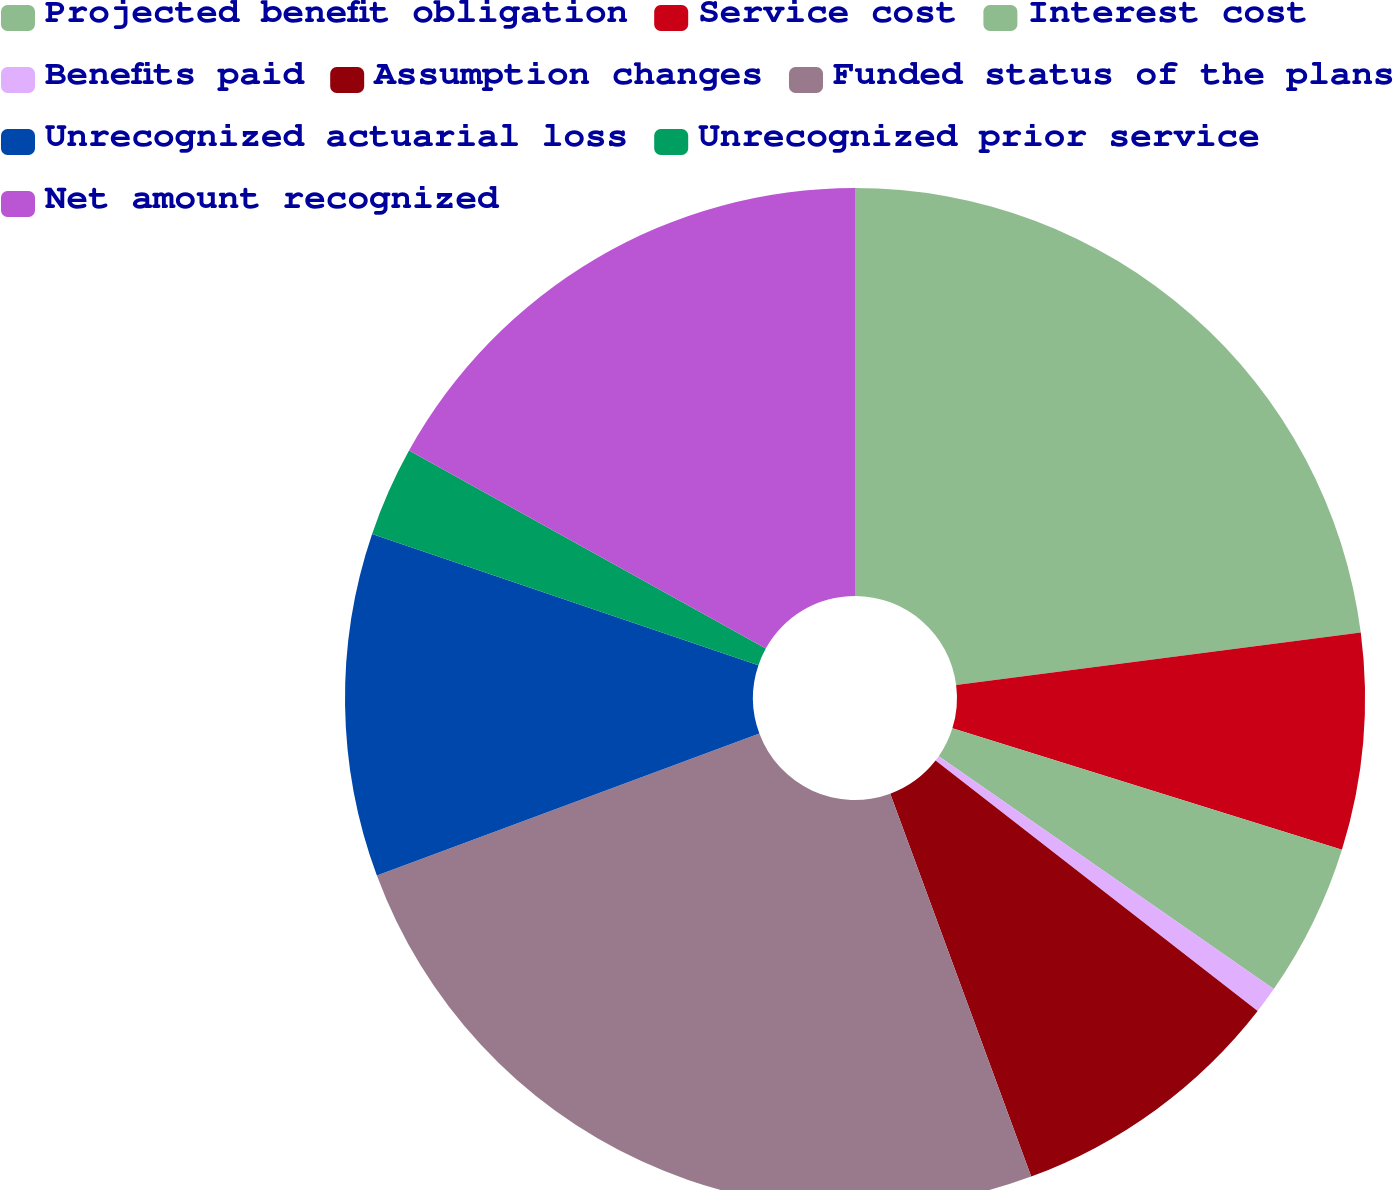Convert chart to OTSL. <chart><loc_0><loc_0><loc_500><loc_500><pie_chart><fcel>Projected benefit obligation<fcel>Service cost<fcel>Interest cost<fcel>Benefits paid<fcel>Assumption changes<fcel>Funded status of the plans<fcel>Unrecognized actuarial loss<fcel>Unrecognized prior service<fcel>Net amount recognized<nl><fcel>22.95%<fcel>6.86%<fcel>4.86%<fcel>0.85%<fcel>8.87%<fcel>24.96%<fcel>10.87%<fcel>2.85%<fcel>16.94%<nl></chart> 